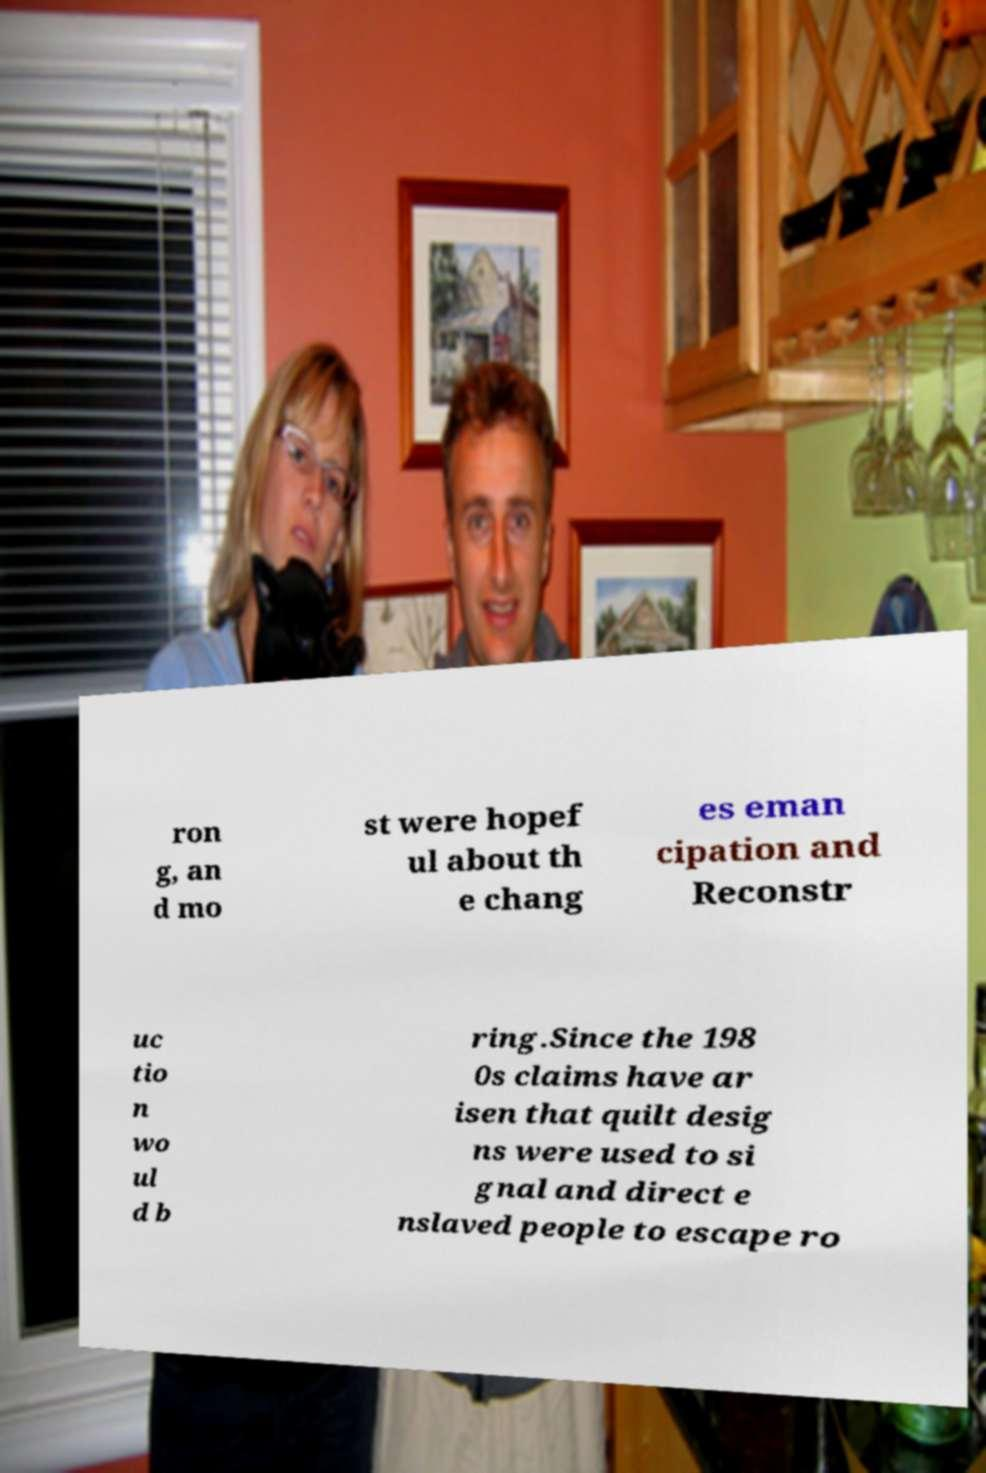Please read and relay the text visible in this image. What does it say? ron g, an d mo st were hopef ul about th e chang es eman cipation and Reconstr uc tio n wo ul d b ring.Since the 198 0s claims have ar isen that quilt desig ns were used to si gnal and direct e nslaved people to escape ro 